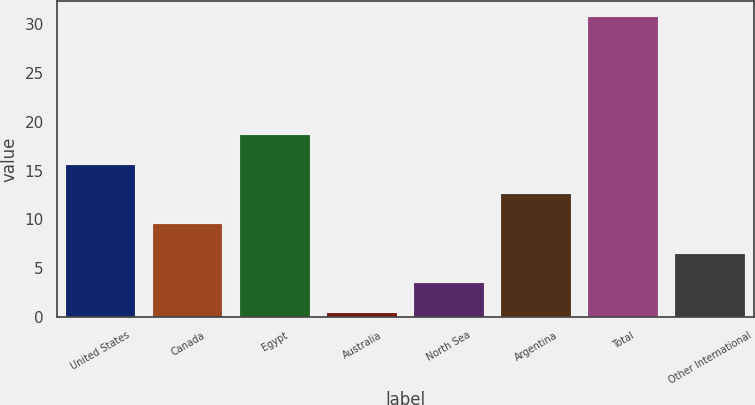Convert chart. <chart><loc_0><loc_0><loc_500><loc_500><bar_chart><fcel>United States<fcel>Canada<fcel>Egypt<fcel>Australia<fcel>North Sea<fcel>Argentina<fcel>Total<fcel>Other International<nl><fcel>15.6<fcel>9.52<fcel>18.7<fcel>0.4<fcel>3.44<fcel>12.56<fcel>30.8<fcel>6.48<nl></chart> 